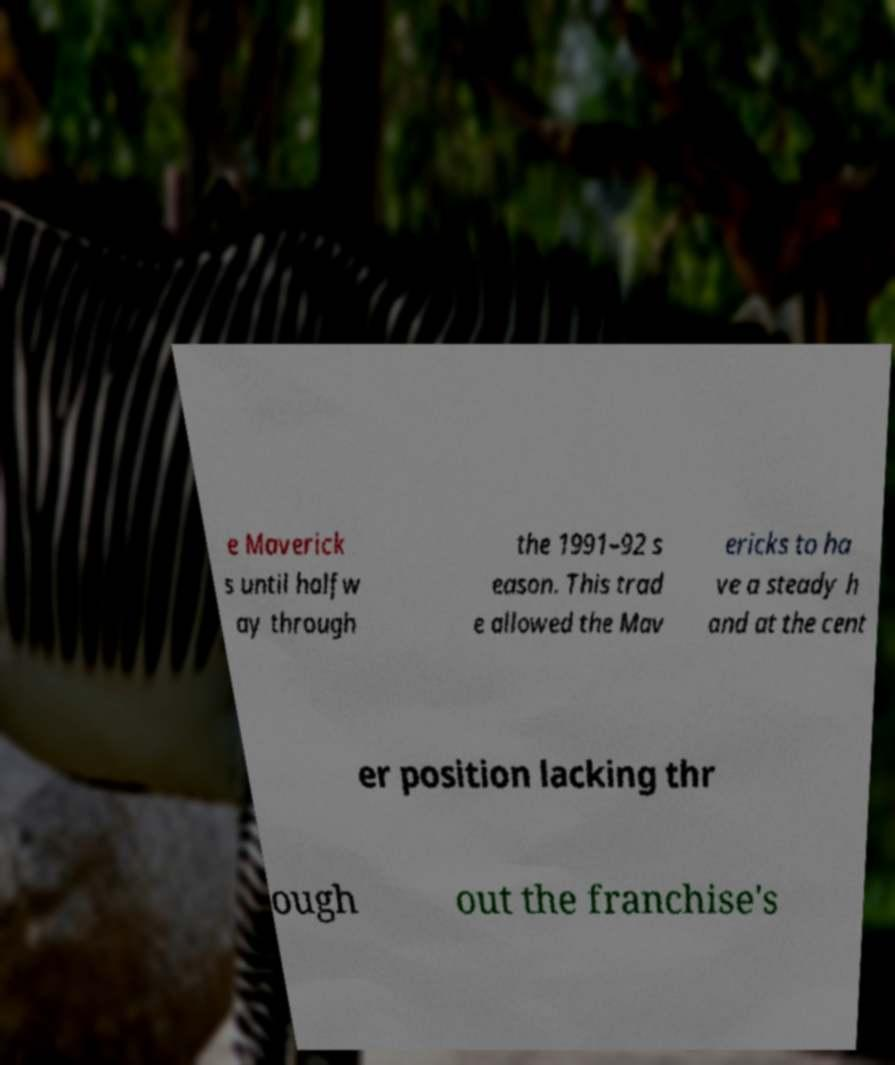I need the written content from this picture converted into text. Can you do that? e Maverick s until halfw ay through the 1991–92 s eason. This trad e allowed the Mav ericks to ha ve a steady h and at the cent er position lacking thr ough out the franchise's 